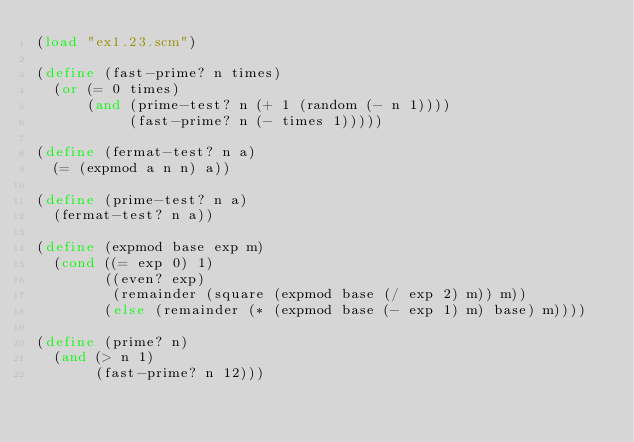Convert code to text. <code><loc_0><loc_0><loc_500><loc_500><_Scheme_>(load "ex1.23.scm")

(define (fast-prime? n times)
  (or (= 0 times)
      (and (prime-test? n (+ 1 (random (- n 1))))
           (fast-prime? n (- times 1)))))

(define (fermat-test? n a)
  (= (expmod a n n) a))

(define (prime-test? n a)
  (fermat-test? n a))

(define (expmod base exp m)
  (cond ((= exp 0) 1)
        ((even? exp)
         (remainder (square (expmod base (/ exp 2) m)) m))
        (else (remainder (* (expmod base (- exp 1) m) base) m))))

(define (prime? n)
  (and (> n 1)
       (fast-prime? n 12)))
</code> 